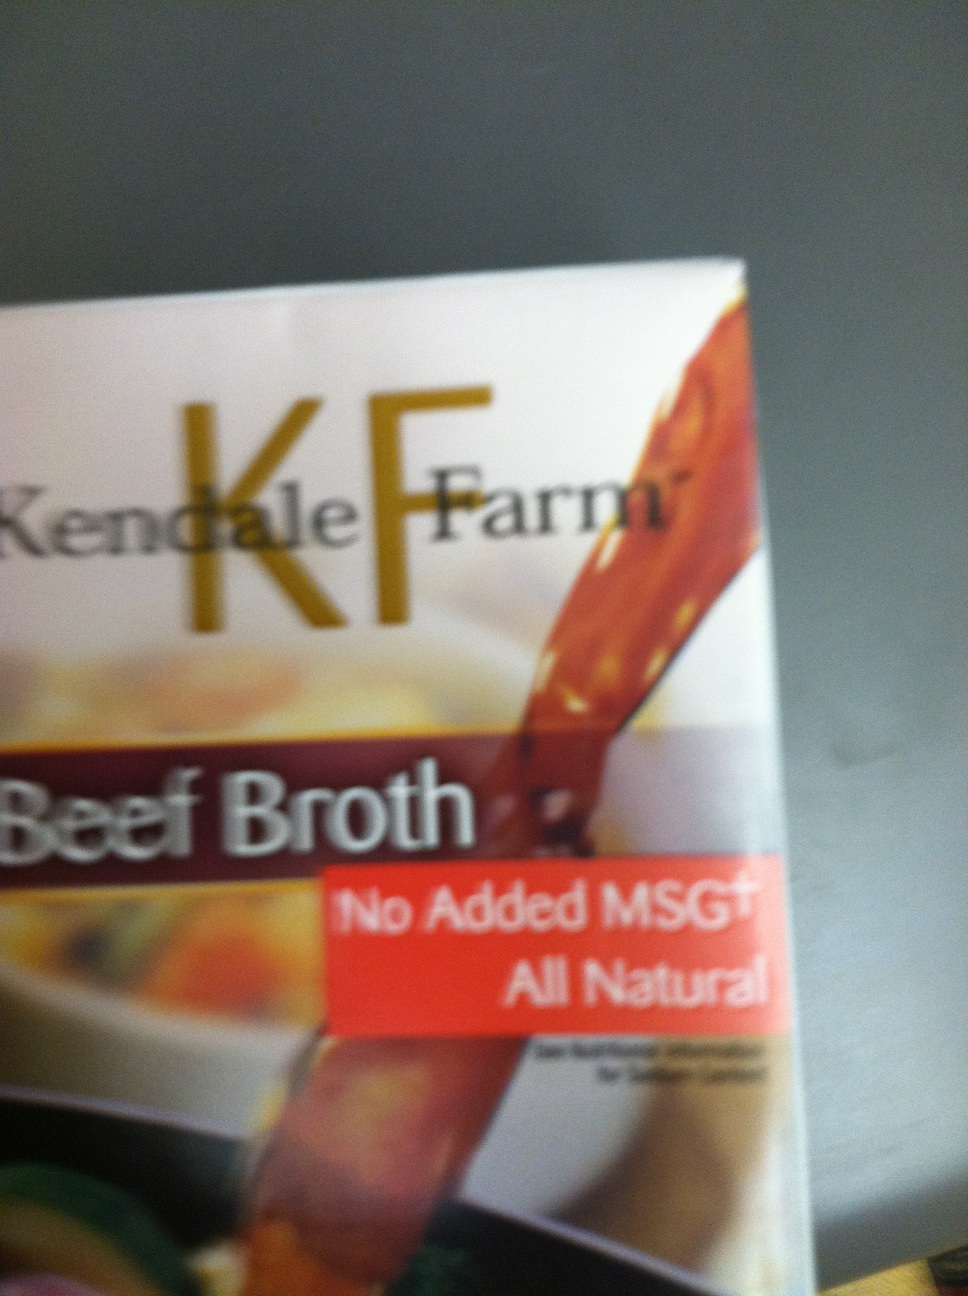What details can you tell from the label? The label indicates this is a product from Kendale Farm and it is beef broth. It prominently mentions two key features: 'No Added MSG' and 'All Natural'. These terms suggest the product is free from monosodium glutamate (a flavor enhancer) and contains natural ingredients without artificial additives. Why is it important that this broth has 'No Added MSG'? Many people are concerned about consuming monosodium glutamate (MSG) because it has been linked to various health issues such as headaches, allergic reactions, and other sensitivities. Additionally, some consumers prefer foods without artificial additives for a more natural diet. The 'No Added MSG' label thus appeals to health-conscious individuals and those with specific dietary restrictions. Imagine a futuristic scenario where this beef broth is used on a space mission. Describe the scene. On board the SS Explorer, the year is 2135, and the spaceship is en route to Mars. The crew gathers in the galley, floating in zero gravity, as they prepare a hearty meal with Kendale Farm Beef Broth. Using the broth, they create a nutrient-rich stew essential for maintaining their health during the long journey. The broth, packed and preserved for space travel, provides not only sustenance but also a sense of comfort and connection to Earth. As they consume their meal, the rich aroma of beef broth fills the air, and for a moment, they forget they are light-years away from home. This small luxury boosts their morale and brings a sense of normalcy in the vast expanse of space. If you could turn this beef broth into a fictional character, what kind of character would it be? Meet Brothimus Maximus, a stalwart guardian of flavor realms! Cloaked in the rich, golden hues of a beef broth, Brothimus is an all-natural warrior, free from additives and preservatives. With a ladle-shaped shield and a spoon-sword, he roams the culinary world protecting the integrity of wholesome ingredients. His special power is enhancing the essence of any dish, fortifying soups and stews with his nourishing presence, and fending off the evil empires of artificial flavors and MSG invaders. His motto: 'Pure, natural, and always flavorful!' 